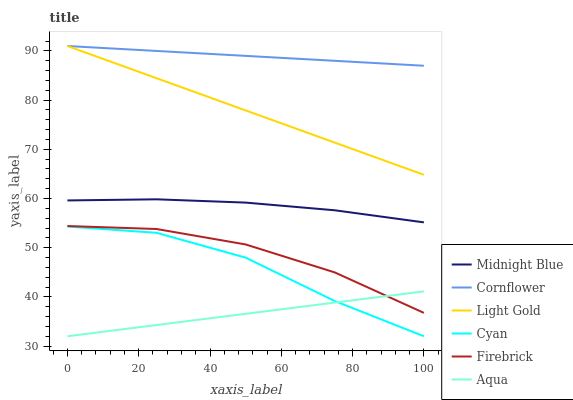Does Midnight Blue have the minimum area under the curve?
Answer yes or no. No. Does Midnight Blue have the maximum area under the curve?
Answer yes or no. No. Is Midnight Blue the smoothest?
Answer yes or no. No. Is Midnight Blue the roughest?
Answer yes or no. No. Does Midnight Blue have the lowest value?
Answer yes or no. No. Does Midnight Blue have the highest value?
Answer yes or no. No. Is Cyan less than Firebrick?
Answer yes or no. Yes. Is Cornflower greater than Midnight Blue?
Answer yes or no. Yes. Does Cyan intersect Firebrick?
Answer yes or no. No. 